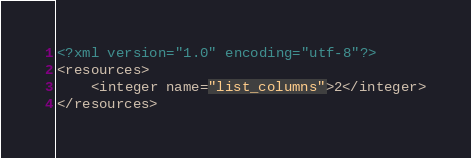Convert code to text. <code><loc_0><loc_0><loc_500><loc_500><_XML_><?xml version="1.0" encoding="utf-8"?>
<resources>
    <integer name="list_columns">2</integer>
</resources></code> 